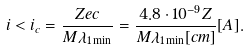Convert formula to latex. <formula><loc_0><loc_0><loc_500><loc_500>i < i _ { c } = \frac { Z e c } { M \lambda _ { 1 \min } } = \frac { 4 . 8 \cdot 1 0 ^ { - 9 } Z } { M \lambda _ { 1 \min } [ c m ] } [ A ] .</formula> 